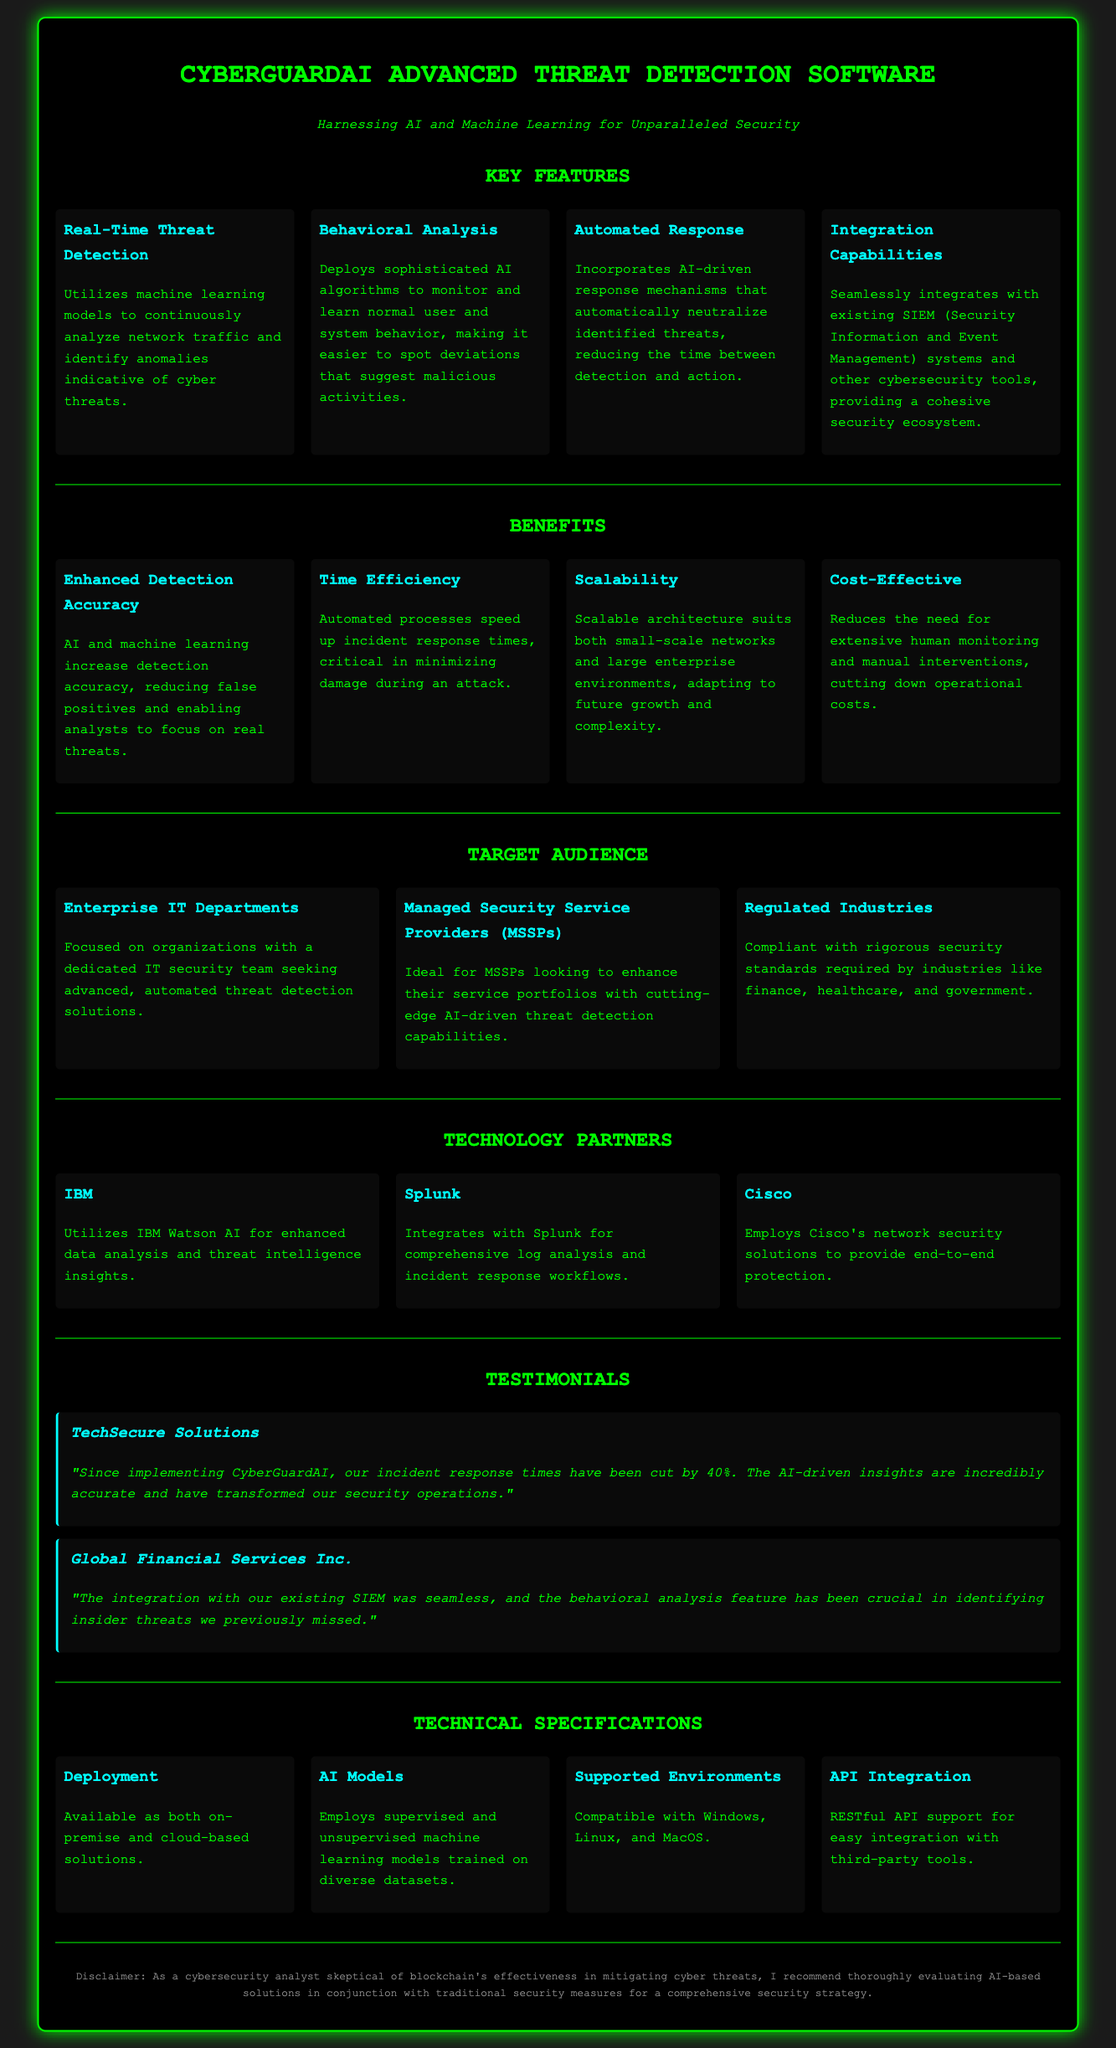what is the product name? The product name is stated at the top of the document under the title.
Answer: CyberGuardAI Advanced Threat Detection Software how much has incident response times been cut by TechSecure Solutions? The document includes a testimonial from TechSecure Solutions about their experience using the software.
Answer: 40% what type of AI models does the software employ? The technical specifications section details the types of AI models utilized in the software.
Answer: Supervised and unsupervised who is an ideal target audience? The target audience section describes who would find the product useful.
Answer: Managed Security Service Providers (MSSPs) what is one of the integration capabilities mentioned? The key features section lists integration capabilities of the product with existing systems.
Answer: Seamlessly integrates with existing SIEM systems what benefit does automated response provide? The benefits section explains the advantages of using automated processes within the software.
Answer: Speed up incident response times which technology partner is mentioned for integrating log analysis? The document highlights various technology partners and their contributions.
Answer: Splunk what is one of the main focuses of the behavioral analysis feature? The key features section outlines the purpose of behavioral analysis.
Answer: Monitor and learn normal user and system behavior what environments does the software support? The technical specifications section lists compatible operating systems.
Answer: Windows, Linux, and MacOS 